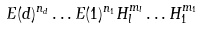<formula> <loc_0><loc_0><loc_500><loc_500>E ( d ) ^ { n _ { d } } \dots E ( 1 ) ^ { n _ { 1 } } H _ { l } ^ { m _ { l } } \dots H _ { 1 } ^ { m _ { 1 } }</formula> 